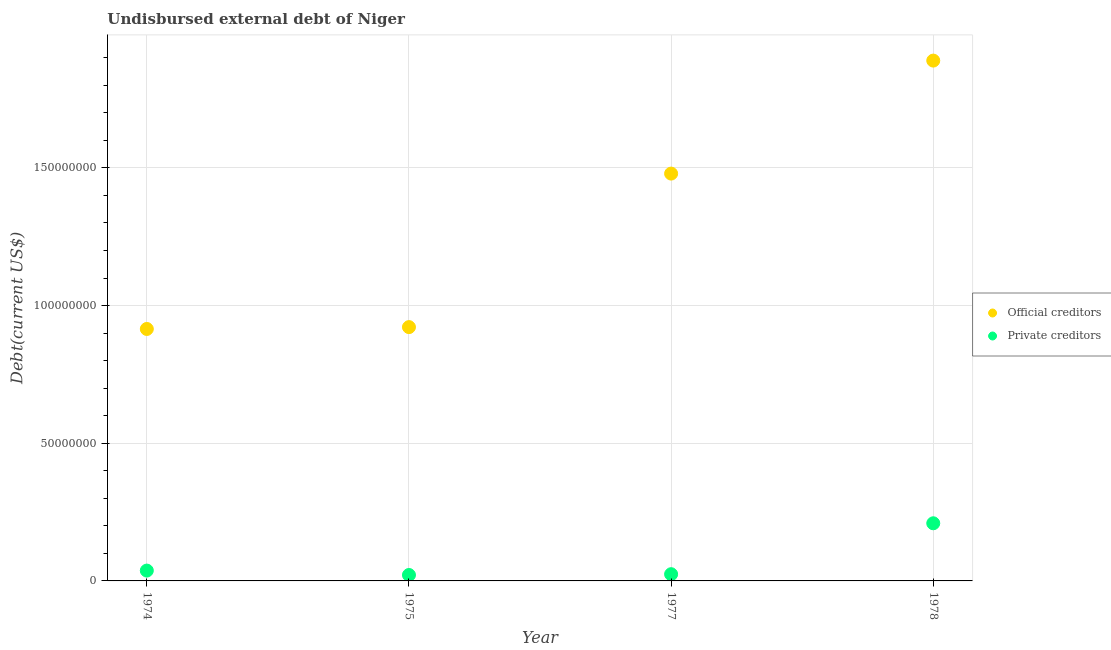How many different coloured dotlines are there?
Your answer should be compact. 2. Is the number of dotlines equal to the number of legend labels?
Provide a succinct answer. Yes. What is the undisbursed external debt of private creditors in 1977?
Your answer should be compact. 2.44e+06. Across all years, what is the maximum undisbursed external debt of official creditors?
Offer a very short reply. 1.89e+08. Across all years, what is the minimum undisbursed external debt of official creditors?
Keep it short and to the point. 9.15e+07. In which year was the undisbursed external debt of official creditors maximum?
Keep it short and to the point. 1978. In which year was the undisbursed external debt of official creditors minimum?
Your answer should be compact. 1974. What is the total undisbursed external debt of private creditors in the graph?
Offer a terse response. 2.93e+07. What is the difference between the undisbursed external debt of official creditors in 1974 and that in 1978?
Make the answer very short. -9.75e+07. What is the difference between the undisbursed external debt of private creditors in 1975 and the undisbursed external debt of official creditors in 1974?
Make the answer very short. -8.94e+07. What is the average undisbursed external debt of private creditors per year?
Make the answer very short. 7.32e+06. In the year 1974, what is the difference between the undisbursed external debt of private creditors and undisbursed external debt of official creditors?
Keep it short and to the point. -8.78e+07. What is the ratio of the undisbursed external debt of private creditors in 1974 to that in 1975?
Your response must be concise. 1.74. What is the difference between the highest and the second highest undisbursed external debt of official creditors?
Provide a short and direct response. 4.10e+07. What is the difference between the highest and the lowest undisbursed external debt of official creditors?
Provide a succinct answer. 9.75e+07. In how many years, is the undisbursed external debt of private creditors greater than the average undisbursed external debt of private creditors taken over all years?
Ensure brevity in your answer.  1. Is the sum of the undisbursed external debt of official creditors in 1974 and 1975 greater than the maximum undisbursed external debt of private creditors across all years?
Your answer should be very brief. Yes. Does the undisbursed external debt of official creditors monotonically increase over the years?
Offer a terse response. Yes. What is the difference between two consecutive major ticks on the Y-axis?
Give a very brief answer. 5.00e+07. Does the graph contain any zero values?
Make the answer very short. No. How many legend labels are there?
Ensure brevity in your answer.  2. What is the title of the graph?
Your answer should be very brief. Undisbursed external debt of Niger. Does "Birth rate" appear as one of the legend labels in the graph?
Your response must be concise. No. What is the label or title of the X-axis?
Your response must be concise. Year. What is the label or title of the Y-axis?
Keep it short and to the point. Debt(current US$). What is the Debt(current US$) of Official creditors in 1974?
Offer a very short reply. 9.15e+07. What is the Debt(current US$) in Private creditors in 1974?
Provide a succinct answer. 3.75e+06. What is the Debt(current US$) in Official creditors in 1975?
Give a very brief answer. 9.22e+07. What is the Debt(current US$) in Private creditors in 1975?
Your response must be concise. 2.15e+06. What is the Debt(current US$) of Official creditors in 1977?
Give a very brief answer. 1.48e+08. What is the Debt(current US$) in Private creditors in 1977?
Your response must be concise. 2.44e+06. What is the Debt(current US$) in Official creditors in 1978?
Give a very brief answer. 1.89e+08. What is the Debt(current US$) of Private creditors in 1978?
Your response must be concise. 2.09e+07. Across all years, what is the maximum Debt(current US$) in Official creditors?
Keep it short and to the point. 1.89e+08. Across all years, what is the maximum Debt(current US$) in Private creditors?
Offer a terse response. 2.09e+07. Across all years, what is the minimum Debt(current US$) in Official creditors?
Give a very brief answer. 9.15e+07. Across all years, what is the minimum Debt(current US$) of Private creditors?
Offer a very short reply. 2.15e+06. What is the total Debt(current US$) in Official creditors in the graph?
Give a very brief answer. 5.21e+08. What is the total Debt(current US$) in Private creditors in the graph?
Your answer should be very brief. 2.93e+07. What is the difference between the Debt(current US$) in Official creditors in 1974 and that in 1975?
Provide a succinct answer. -6.75e+05. What is the difference between the Debt(current US$) in Private creditors in 1974 and that in 1975?
Offer a terse response. 1.60e+06. What is the difference between the Debt(current US$) of Official creditors in 1974 and that in 1977?
Provide a short and direct response. -5.64e+07. What is the difference between the Debt(current US$) in Private creditors in 1974 and that in 1977?
Ensure brevity in your answer.  1.31e+06. What is the difference between the Debt(current US$) of Official creditors in 1974 and that in 1978?
Your response must be concise. -9.75e+07. What is the difference between the Debt(current US$) of Private creditors in 1974 and that in 1978?
Provide a short and direct response. -1.72e+07. What is the difference between the Debt(current US$) of Official creditors in 1975 and that in 1977?
Offer a terse response. -5.58e+07. What is the difference between the Debt(current US$) of Official creditors in 1975 and that in 1978?
Give a very brief answer. -9.68e+07. What is the difference between the Debt(current US$) of Private creditors in 1975 and that in 1978?
Ensure brevity in your answer.  -1.88e+07. What is the difference between the Debt(current US$) in Official creditors in 1977 and that in 1978?
Provide a short and direct response. -4.10e+07. What is the difference between the Debt(current US$) of Private creditors in 1977 and that in 1978?
Make the answer very short. -1.85e+07. What is the difference between the Debt(current US$) in Official creditors in 1974 and the Debt(current US$) in Private creditors in 1975?
Keep it short and to the point. 8.94e+07. What is the difference between the Debt(current US$) in Official creditors in 1974 and the Debt(current US$) in Private creditors in 1977?
Offer a terse response. 8.91e+07. What is the difference between the Debt(current US$) in Official creditors in 1974 and the Debt(current US$) in Private creditors in 1978?
Your response must be concise. 7.06e+07. What is the difference between the Debt(current US$) in Official creditors in 1975 and the Debt(current US$) in Private creditors in 1977?
Offer a terse response. 8.97e+07. What is the difference between the Debt(current US$) in Official creditors in 1975 and the Debt(current US$) in Private creditors in 1978?
Your answer should be very brief. 7.12e+07. What is the difference between the Debt(current US$) of Official creditors in 1977 and the Debt(current US$) of Private creditors in 1978?
Provide a short and direct response. 1.27e+08. What is the average Debt(current US$) of Official creditors per year?
Offer a terse response. 1.30e+08. What is the average Debt(current US$) in Private creditors per year?
Offer a very short reply. 7.32e+06. In the year 1974, what is the difference between the Debt(current US$) in Official creditors and Debt(current US$) in Private creditors?
Provide a short and direct response. 8.78e+07. In the year 1975, what is the difference between the Debt(current US$) in Official creditors and Debt(current US$) in Private creditors?
Your answer should be very brief. 9.00e+07. In the year 1977, what is the difference between the Debt(current US$) of Official creditors and Debt(current US$) of Private creditors?
Provide a short and direct response. 1.45e+08. In the year 1978, what is the difference between the Debt(current US$) in Official creditors and Debt(current US$) in Private creditors?
Give a very brief answer. 1.68e+08. What is the ratio of the Debt(current US$) in Official creditors in 1974 to that in 1975?
Make the answer very short. 0.99. What is the ratio of the Debt(current US$) of Private creditors in 1974 to that in 1975?
Offer a very short reply. 1.74. What is the ratio of the Debt(current US$) of Official creditors in 1974 to that in 1977?
Keep it short and to the point. 0.62. What is the ratio of the Debt(current US$) in Private creditors in 1974 to that in 1977?
Offer a very short reply. 1.54. What is the ratio of the Debt(current US$) in Official creditors in 1974 to that in 1978?
Provide a short and direct response. 0.48. What is the ratio of the Debt(current US$) in Private creditors in 1974 to that in 1978?
Make the answer very short. 0.18. What is the ratio of the Debt(current US$) of Official creditors in 1975 to that in 1977?
Ensure brevity in your answer.  0.62. What is the ratio of the Debt(current US$) in Private creditors in 1975 to that in 1977?
Keep it short and to the point. 0.88. What is the ratio of the Debt(current US$) of Official creditors in 1975 to that in 1978?
Offer a terse response. 0.49. What is the ratio of the Debt(current US$) of Private creditors in 1975 to that in 1978?
Your response must be concise. 0.1. What is the ratio of the Debt(current US$) in Official creditors in 1977 to that in 1978?
Give a very brief answer. 0.78. What is the ratio of the Debt(current US$) in Private creditors in 1977 to that in 1978?
Keep it short and to the point. 0.12. What is the difference between the highest and the second highest Debt(current US$) in Official creditors?
Offer a very short reply. 4.10e+07. What is the difference between the highest and the second highest Debt(current US$) in Private creditors?
Keep it short and to the point. 1.72e+07. What is the difference between the highest and the lowest Debt(current US$) of Official creditors?
Offer a terse response. 9.75e+07. What is the difference between the highest and the lowest Debt(current US$) in Private creditors?
Keep it short and to the point. 1.88e+07. 